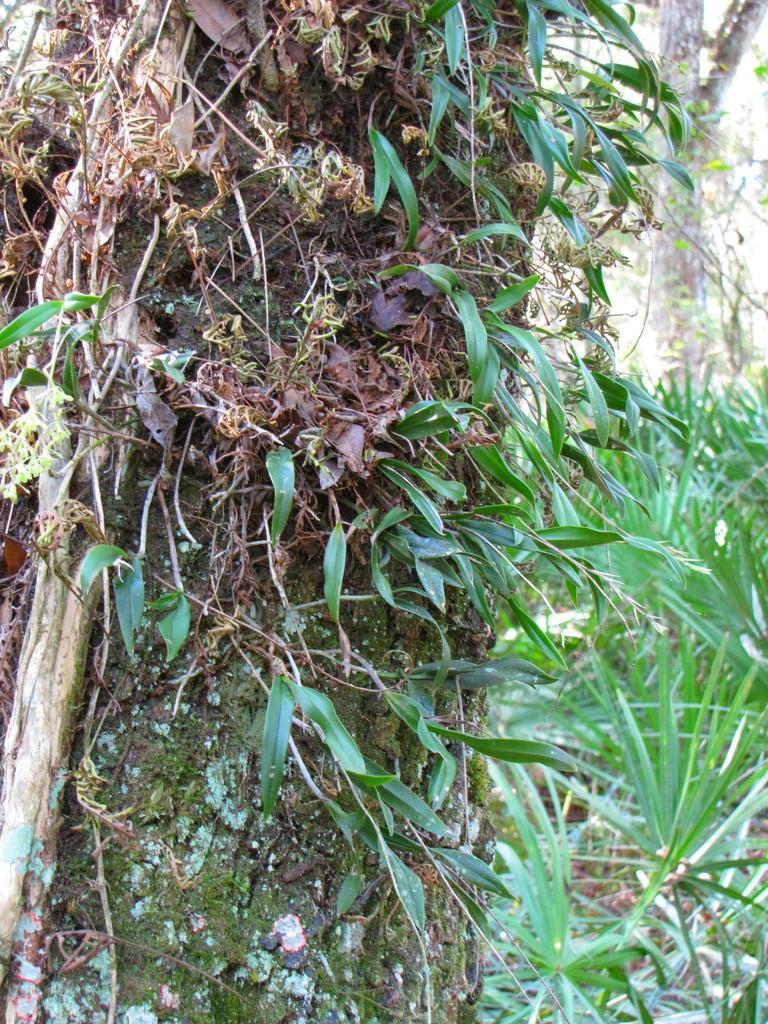Could you give a brief overview of what you see in this image? In this picture we can see tree trunks, leaves and plants. 